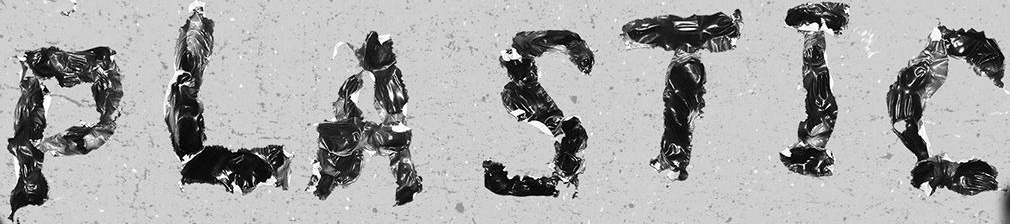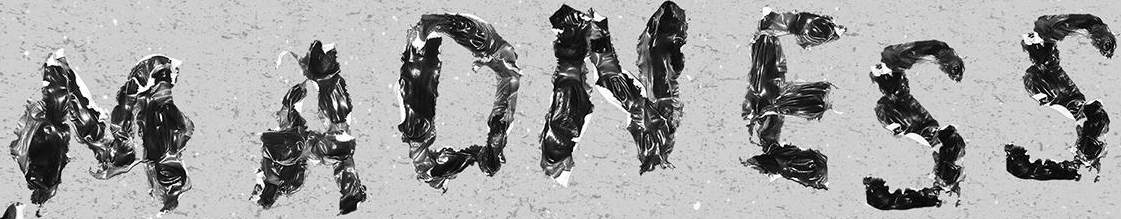Read the text from these images in sequence, separated by a semicolon. PLASTIC; MADNESS 